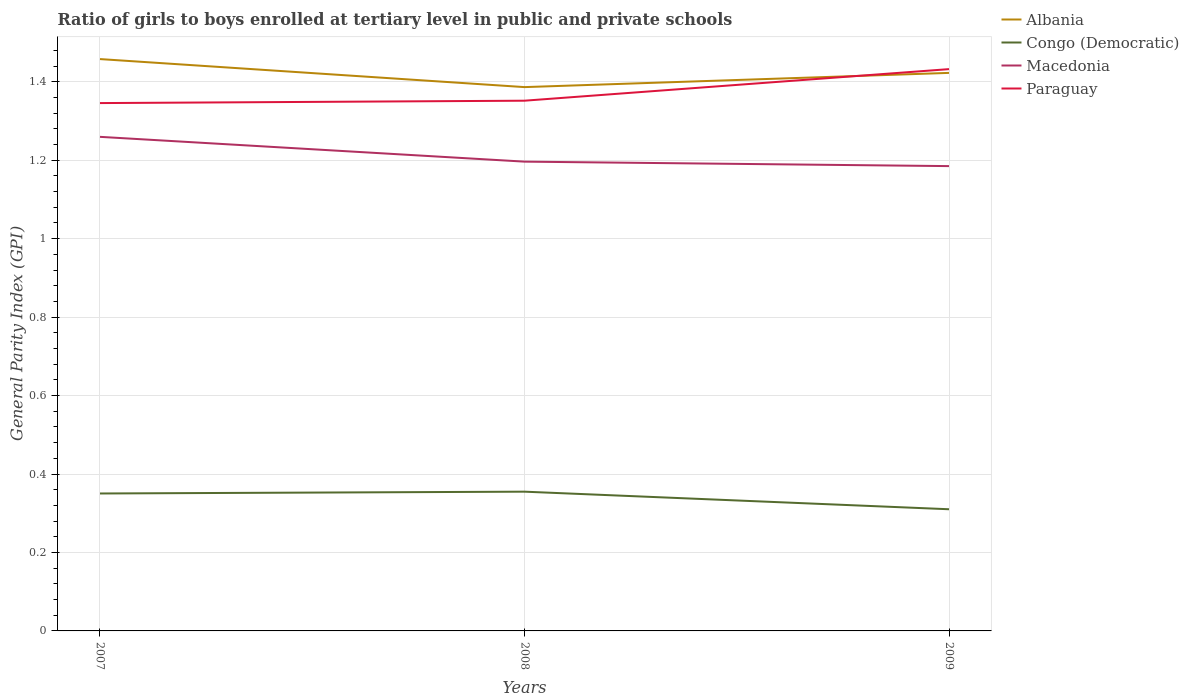Across all years, what is the maximum general parity index in Macedonia?
Give a very brief answer. 1.18. What is the total general parity index in Paraguay in the graph?
Offer a terse response. -0.09. What is the difference between the highest and the second highest general parity index in Macedonia?
Your response must be concise. 0.07. What is the difference between the highest and the lowest general parity index in Paraguay?
Offer a very short reply. 1. Is the general parity index in Macedonia strictly greater than the general parity index in Paraguay over the years?
Offer a very short reply. Yes. How many years are there in the graph?
Offer a very short reply. 3. Does the graph contain any zero values?
Provide a succinct answer. No. How many legend labels are there?
Your answer should be compact. 4. How are the legend labels stacked?
Offer a terse response. Vertical. What is the title of the graph?
Your answer should be compact. Ratio of girls to boys enrolled at tertiary level in public and private schools. What is the label or title of the Y-axis?
Offer a terse response. General Parity Index (GPI). What is the General Parity Index (GPI) of Albania in 2007?
Provide a succinct answer. 1.46. What is the General Parity Index (GPI) of Congo (Democratic) in 2007?
Provide a short and direct response. 0.35. What is the General Parity Index (GPI) in Macedonia in 2007?
Keep it short and to the point. 1.26. What is the General Parity Index (GPI) of Paraguay in 2007?
Your answer should be very brief. 1.35. What is the General Parity Index (GPI) in Albania in 2008?
Make the answer very short. 1.39. What is the General Parity Index (GPI) of Congo (Democratic) in 2008?
Your response must be concise. 0.35. What is the General Parity Index (GPI) in Macedonia in 2008?
Provide a short and direct response. 1.2. What is the General Parity Index (GPI) of Paraguay in 2008?
Your answer should be very brief. 1.35. What is the General Parity Index (GPI) of Albania in 2009?
Give a very brief answer. 1.42. What is the General Parity Index (GPI) of Congo (Democratic) in 2009?
Offer a very short reply. 0.31. What is the General Parity Index (GPI) of Macedonia in 2009?
Offer a very short reply. 1.18. What is the General Parity Index (GPI) of Paraguay in 2009?
Provide a succinct answer. 1.43. Across all years, what is the maximum General Parity Index (GPI) in Albania?
Your answer should be compact. 1.46. Across all years, what is the maximum General Parity Index (GPI) of Congo (Democratic)?
Provide a short and direct response. 0.35. Across all years, what is the maximum General Parity Index (GPI) in Macedonia?
Provide a succinct answer. 1.26. Across all years, what is the maximum General Parity Index (GPI) in Paraguay?
Your answer should be very brief. 1.43. Across all years, what is the minimum General Parity Index (GPI) of Albania?
Your answer should be very brief. 1.39. Across all years, what is the minimum General Parity Index (GPI) in Congo (Democratic)?
Your answer should be compact. 0.31. Across all years, what is the minimum General Parity Index (GPI) of Macedonia?
Your answer should be very brief. 1.18. Across all years, what is the minimum General Parity Index (GPI) of Paraguay?
Offer a very short reply. 1.35. What is the total General Parity Index (GPI) in Albania in the graph?
Ensure brevity in your answer.  4.27. What is the total General Parity Index (GPI) of Congo (Democratic) in the graph?
Your answer should be compact. 1.02. What is the total General Parity Index (GPI) in Macedonia in the graph?
Keep it short and to the point. 3.64. What is the total General Parity Index (GPI) in Paraguay in the graph?
Offer a very short reply. 4.13. What is the difference between the General Parity Index (GPI) in Albania in 2007 and that in 2008?
Your answer should be very brief. 0.07. What is the difference between the General Parity Index (GPI) in Congo (Democratic) in 2007 and that in 2008?
Keep it short and to the point. -0. What is the difference between the General Parity Index (GPI) of Macedonia in 2007 and that in 2008?
Ensure brevity in your answer.  0.06. What is the difference between the General Parity Index (GPI) of Paraguay in 2007 and that in 2008?
Provide a succinct answer. -0.01. What is the difference between the General Parity Index (GPI) of Albania in 2007 and that in 2009?
Your answer should be compact. 0.04. What is the difference between the General Parity Index (GPI) in Congo (Democratic) in 2007 and that in 2009?
Provide a succinct answer. 0.04. What is the difference between the General Parity Index (GPI) of Macedonia in 2007 and that in 2009?
Make the answer very short. 0.07. What is the difference between the General Parity Index (GPI) in Paraguay in 2007 and that in 2009?
Ensure brevity in your answer.  -0.09. What is the difference between the General Parity Index (GPI) of Albania in 2008 and that in 2009?
Provide a succinct answer. -0.04. What is the difference between the General Parity Index (GPI) of Congo (Democratic) in 2008 and that in 2009?
Offer a terse response. 0.04. What is the difference between the General Parity Index (GPI) of Macedonia in 2008 and that in 2009?
Give a very brief answer. 0.01. What is the difference between the General Parity Index (GPI) in Paraguay in 2008 and that in 2009?
Ensure brevity in your answer.  -0.08. What is the difference between the General Parity Index (GPI) of Albania in 2007 and the General Parity Index (GPI) of Congo (Democratic) in 2008?
Provide a succinct answer. 1.1. What is the difference between the General Parity Index (GPI) of Albania in 2007 and the General Parity Index (GPI) of Macedonia in 2008?
Your answer should be very brief. 0.26. What is the difference between the General Parity Index (GPI) of Albania in 2007 and the General Parity Index (GPI) of Paraguay in 2008?
Provide a succinct answer. 0.11. What is the difference between the General Parity Index (GPI) in Congo (Democratic) in 2007 and the General Parity Index (GPI) in Macedonia in 2008?
Provide a succinct answer. -0.85. What is the difference between the General Parity Index (GPI) of Congo (Democratic) in 2007 and the General Parity Index (GPI) of Paraguay in 2008?
Ensure brevity in your answer.  -1. What is the difference between the General Parity Index (GPI) in Macedonia in 2007 and the General Parity Index (GPI) in Paraguay in 2008?
Offer a terse response. -0.09. What is the difference between the General Parity Index (GPI) in Albania in 2007 and the General Parity Index (GPI) in Congo (Democratic) in 2009?
Your answer should be very brief. 1.15. What is the difference between the General Parity Index (GPI) of Albania in 2007 and the General Parity Index (GPI) of Macedonia in 2009?
Offer a terse response. 0.27. What is the difference between the General Parity Index (GPI) of Albania in 2007 and the General Parity Index (GPI) of Paraguay in 2009?
Provide a short and direct response. 0.03. What is the difference between the General Parity Index (GPI) of Congo (Democratic) in 2007 and the General Parity Index (GPI) of Macedonia in 2009?
Your response must be concise. -0.83. What is the difference between the General Parity Index (GPI) of Congo (Democratic) in 2007 and the General Parity Index (GPI) of Paraguay in 2009?
Provide a short and direct response. -1.08. What is the difference between the General Parity Index (GPI) in Macedonia in 2007 and the General Parity Index (GPI) in Paraguay in 2009?
Make the answer very short. -0.17. What is the difference between the General Parity Index (GPI) of Albania in 2008 and the General Parity Index (GPI) of Congo (Democratic) in 2009?
Offer a terse response. 1.08. What is the difference between the General Parity Index (GPI) in Albania in 2008 and the General Parity Index (GPI) in Macedonia in 2009?
Your answer should be compact. 0.2. What is the difference between the General Parity Index (GPI) of Albania in 2008 and the General Parity Index (GPI) of Paraguay in 2009?
Offer a very short reply. -0.05. What is the difference between the General Parity Index (GPI) of Congo (Democratic) in 2008 and the General Parity Index (GPI) of Macedonia in 2009?
Keep it short and to the point. -0.83. What is the difference between the General Parity Index (GPI) of Congo (Democratic) in 2008 and the General Parity Index (GPI) of Paraguay in 2009?
Your answer should be compact. -1.08. What is the difference between the General Parity Index (GPI) in Macedonia in 2008 and the General Parity Index (GPI) in Paraguay in 2009?
Offer a terse response. -0.24. What is the average General Parity Index (GPI) in Albania per year?
Provide a short and direct response. 1.42. What is the average General Parity Index (GPI) of Congo (Democratic) per year?
Give a very brief answer. 0.34. What is the average General Parity Index (GPI) of Macedonia per year?
Provide a short and direct response. 1.21. What is the average General Parity Index (GPI) of Paraguay per year?
Provide a short and direct response. 1.38. In the year 2007, what is the difference between the General Parity Index (GPI) in Albania and General Parity Index (GPI) in Congo (Democratic)?
Give a very brief answer. 1.11. In the year 2007, what is the difference between the General Parity Index (GPI) in Albania and General Parity Index (GPI) in Macedonia?
Keep it short and to the point. 0.2. In the year 2007, what is the difference between the General Parity Index (GPI) in Albania and General Parity Index (GPI) in Paraguay?
Your answer should be very brief. 0.11. In the year 2007, what is the difference between the General Parity Index (GPI) in Congo (Democratic) and General Parity Index (GPI) in Macedonia?
Provide a succinct answer. -0.91. In the year 2007, what is the difference between the General Parity Index (GPI) in Congo (Democratic) and General Parity Index (GPI) in Paraguay?
Give a very brief answer. -1. In the year 2007, what is the difference between the General Parity Index (GPI) in Macedonia and General Parity Index (GPI) in Paraguay?
Make the answer very short. -0.09. In the year 2008, what is the difference between the General Parity Index (GPI) in Albania and General Parity Index (GPI) in Congo (Democratic)?
Ensure brevity in your answer.  1.03. In the year 2008, what is the difference between the General Parity Index (GPI) in Albania and General Parity Index (GPI) in Macedonia?
Give a very brief answer. 0.19. In the year 2008, what is the difference between the General Parity Index (GPI) in Albania and General Parity Index (GPI) in Paraguay?
Your answer should be compact. 0.03. In the year 2008, what is the difference between the General Parity Index (GPI) of Congo (Democratic) and General Parity Index (GPI) of Macedonia?
Provide a short and direct response. -0.84. In the year 2008, what is the difference between the General Parity Index (GPI) in Congo (Democratic) and General Parity Index (GPI) in Paraguay?
Offer a terse response. -1. In the year 2008, what is the difference between the General Parity Index (GPI) in Macedonia and General Parity Index (GPI) in Paraguay?
Your answer should be compact. -0.16. In the year 2009, what is the difference between the General Parity Index (GPI) in Albania and General Parity Index (GPI) in Congo (Democratic)?
Offer a very short reply. 1.11. In the year 2009, what is the difference between the General Parity Index (GPI) of Albania and General Parity Index (GPI) of Macedonia?
Give a very brief answer. 0.24. In the year 2009, what is the difference between the General Parity Index (GPI) in Albania and General Parity Index (GPI) in Paraguay?
Offer a very short reply. -0.01. In the year 2009, what is the difference between the General Parity Index (GPI) of Congo (Democratic) and General Parity Index (GPI) of Macedonia?
Your answer should be compact. -0.87. In the year 2009, what is the difference between the General Parity Index (GPI) of Congo (Democratic) and General Parity Index (GPI) of Paraguay?
Keep it short and to the point. -1.12. In the year 2009, what is the difference between the General Parity Index (GPI) in Macedonia and General Parity Index (GPI) in Paraguay?
Keep it short and to the point. -0.25. What is the ratio of the General Parity Index (GPI) in Albania in 2007 to that in 2008?
Offer a very short reply. 1.05. What is the ratio of the General Parity Index (GPI) in Congo (Democratic) in 2007 to that in 2008?
Your response must be concise. 0.99. What is the ratio of the General Parity Index (GPI) in Macedonia in 2007 to that in 2008?
Your response must be concise. 1.05. What is the ratio of the General Parity Index (GPI) in Paraguay in 2007 to that in 2008?
Provide a short and direct response. 1. What is the ratio of the General Parity Index (GPI) of Albania in 2007 to that in 2009?
Give a very brief answer. 1.02. What is the ratio of the General Parity Index (GPI) in Congo (Democratic) in 2007 to that in 2009?
Provide a succinct answer. 1.13. What is the ratio of the General Parity Index (GPI) of Macedonia in 2007 to that in 2009?
Keep it short and to the point. 1.06. What is the ratio of the General Parity Index (GPI) of Paraguay in 2007 to that in 2009?
Make the answer very short. 0.94. What is the ratio of the General Parity Index (GPI) in Albania in 2008 to that in 2009?
Offer a very short reply. 0.97. What is the ratio of the General Parity Index (GPI) in Congo (Democratic) in 2008 to that in 2009?
Your answer should be compact. 1.14. What is the ratio of the General Parity Index (GPI) in Macedonia in 2008 to that in 2009?
Keep it short and to the point. 1.01. What is the ratio of the General Parity Index (GPI) in Paraguay in 2008 to that in 2009?
Offer a terse response. 0.94. What is the difference between the highest and the second highest General Parity Index (GPI) of Albania?
Your response must be concise. 0.04. What is the difference between the highest and the second highest General Parity Index (GPI) in Congo (Democratic)?
Your answer should be compact. 0. What is the difference between the highest and the second highest General Parity Index (GPI) in Macedonia?
Your answer should be very brief. 0.06. What is the difference between the highest and the second highest General Parity Index (GPI) in Paraguay?
Give a very brief answer. 0.08. What is the difference between the highest and the lowest General Parity Index (GPI) of Albania?
Provide a short and direct response. 0.07. What is the difference between the highest and the lowest General Parity Index (GPI) of Congo (Democratic)?
Make the answer very short. 0.04. What is the difference between the highest and the lowest General Parity Index (GPI) of Macedonia?
Offer a very short reply. 0.07. What is the difference between the highest and the lowest General Parity Index (GPI) of Paraguay?
Offer a terse response. 0.09. 